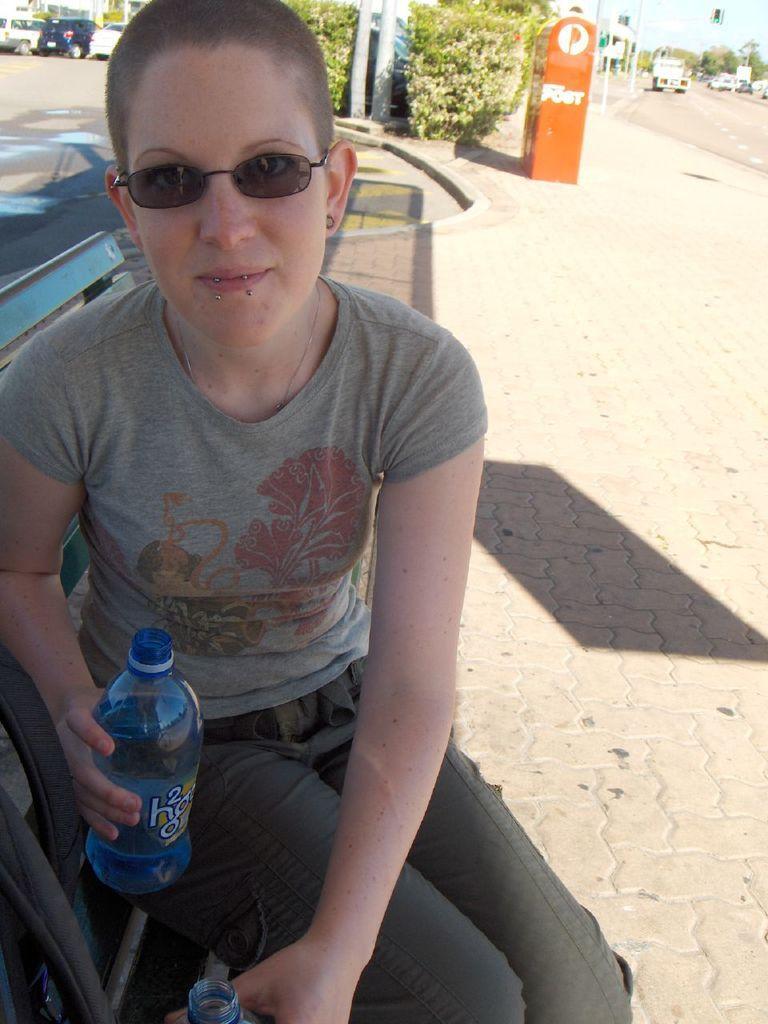How would you summarize this image in a sentence or two? This is the woman sitting on the bench and holding water bottle in her hand. At background I can see few cars parked. This is the trees. I can see a orange color object. I think these are the poles. I can see a truck moving on the road. 